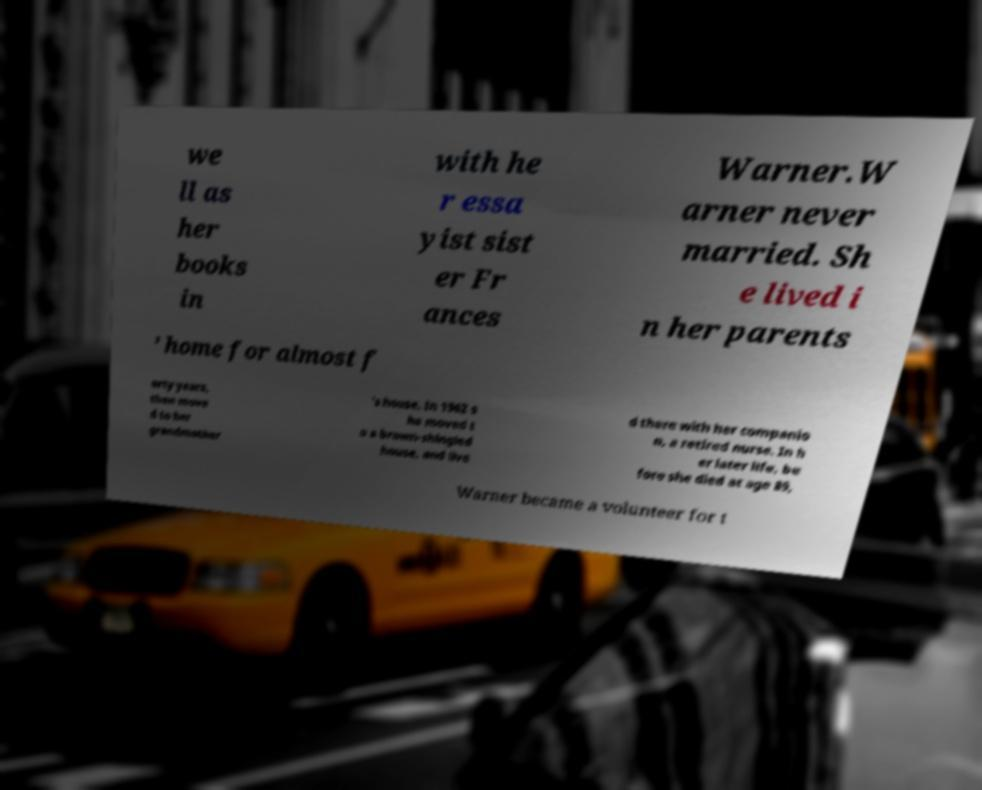For documentation purposes, I need the text within this image transcribed. Could you provide that? we ll as her books in with he r essa yist sist er Fr ances Warner.W arner never married. Sh e lived i n her parents ’ home for almost f orty years, then move d to her grandmother 's house. In 1962 s he moved t o a brown-shingled house, and live d there with her companio n, a retired nurse. In h er later life, be fore she died at age 89, Warner became a volunteer for t 